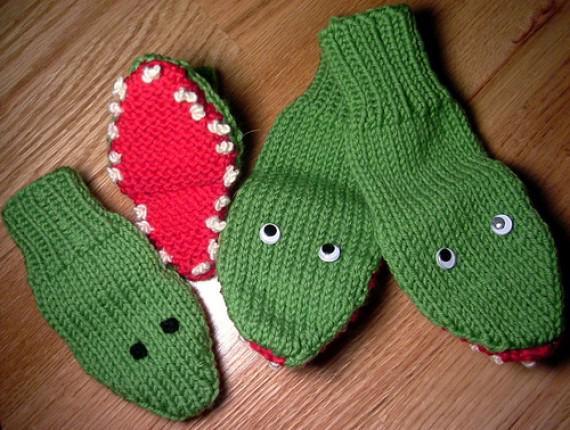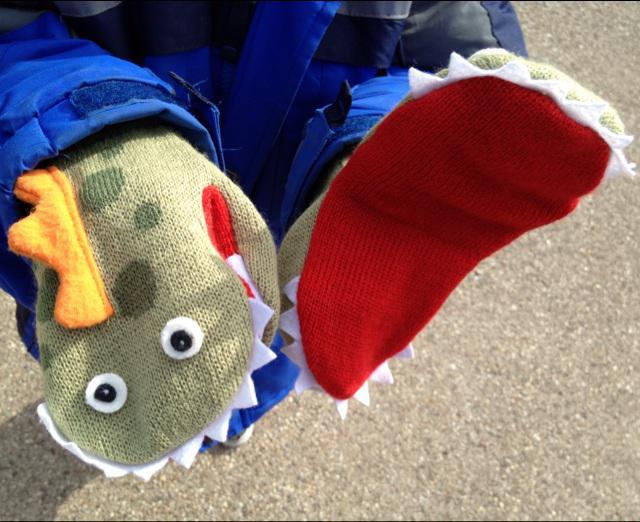The first image is the image on the left, the second image is the image on the right. For the images shown, is this caption "An image shows one pair of blue mittens with cartoon-like eyes, and no other mittens." true? Answer yes or no. No. 